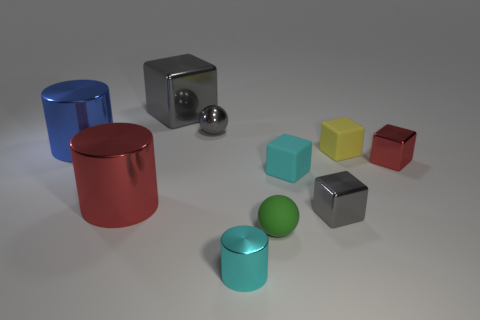Are there more red things that are behind the big metallic cube than big blue metallic cylinders?
Give a very brief answer. No. What number of tiny rubber objects are in front of the cyan thing behind the gray metal cube to the right of the large gray object?
Offer a very short reply. 1. There is a small cyan object behind the green ball; is its shape the same as the green object?
Offer a terse response. No. There is a gray block that is to the left of the rubber sphere; what material is it?
Provide a short and direct response. Metal. What shape is the rubber object that is in front of the yellow matte object and behind the tiny green rubber thing?
Offer a terse response. Cube. What is the big red thing made of?
Your answer should be compact. Metal. What number of blocks are things or yellow rubber objects?
Keep it short and to the point. 5. Is the material of the tiny green thing the same as the large gray cube?
Provide a succinct answer. No. There is a cyan shiny thing that is the same shape as the large blue metallic thing; what is its size?
Your response must be concise. Small. What is the material of the cylinder that is in front of the blue cylinder and behind the small green thing?
Give a very brief answer. Metal. 